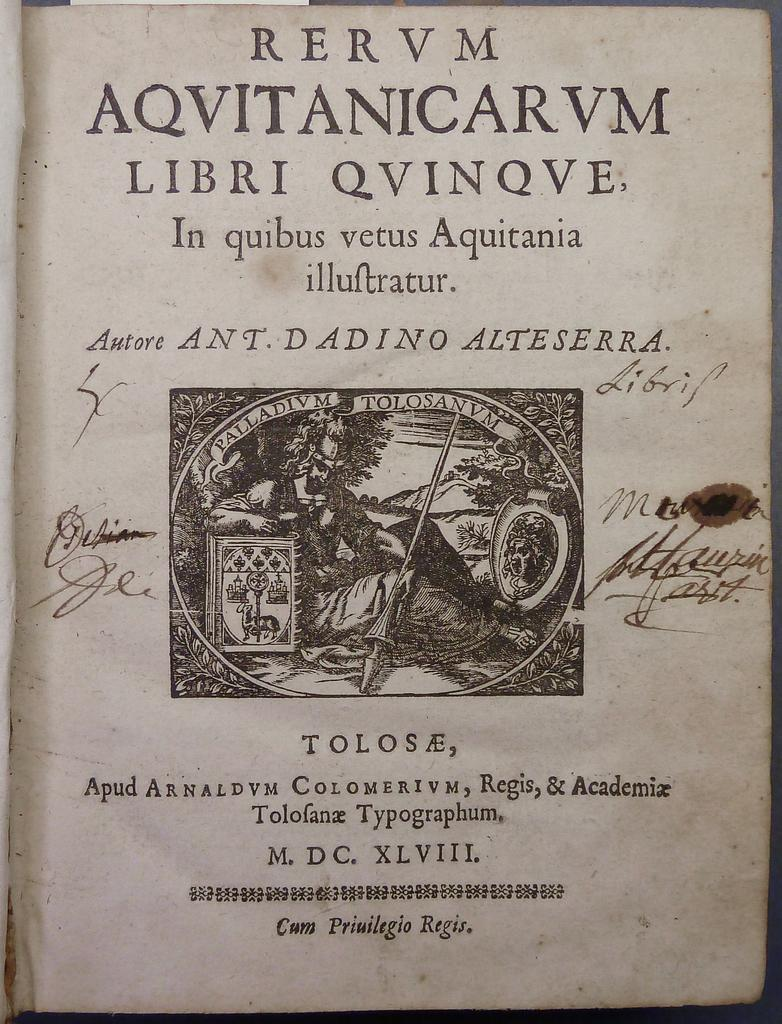<image>
Give a short and clear explanation of the subsequent image. A page in an old book that says Rervm Aqvitanicarvm Libri Qvinqve. 